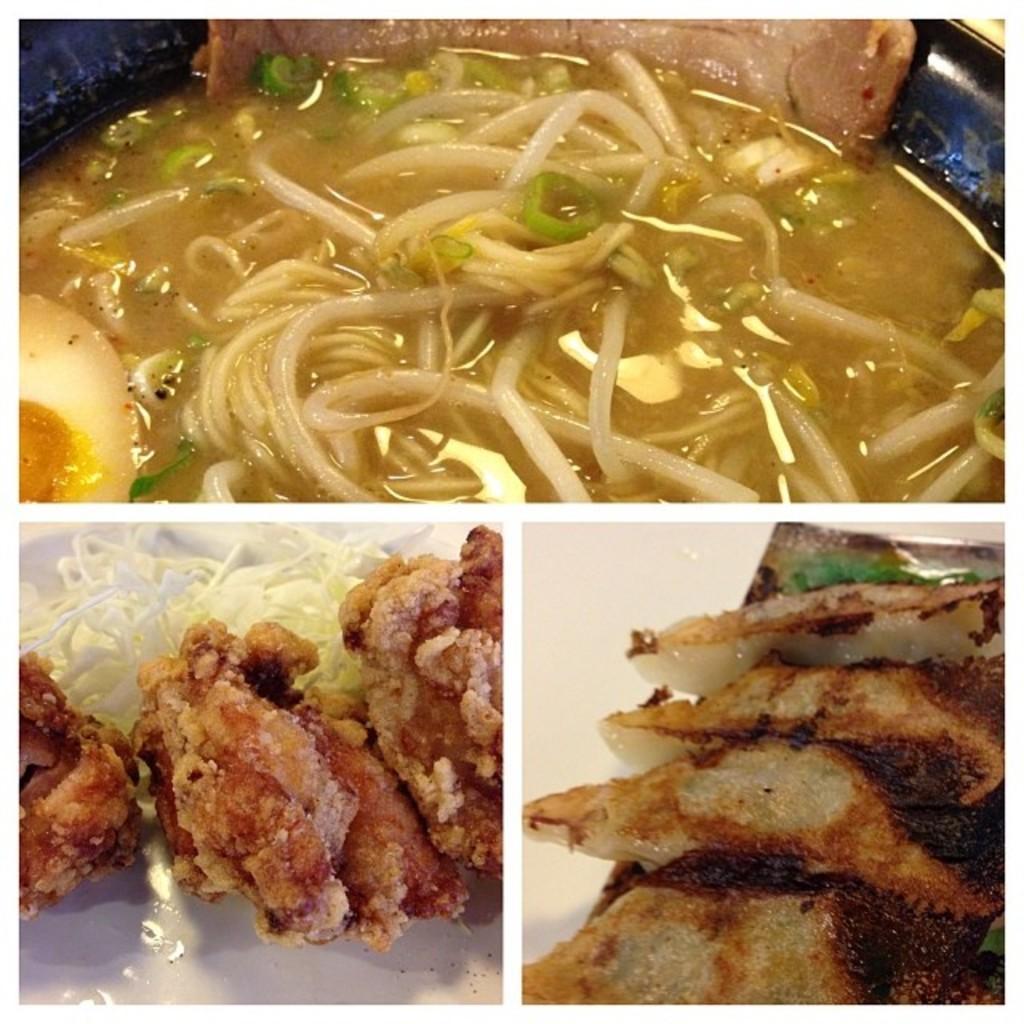How would you summarize this image in a sentence or two? In this image there is a collage image of a three different food items as we can see there is a noodle at top of this image and there are some other food items at bottom of this image 